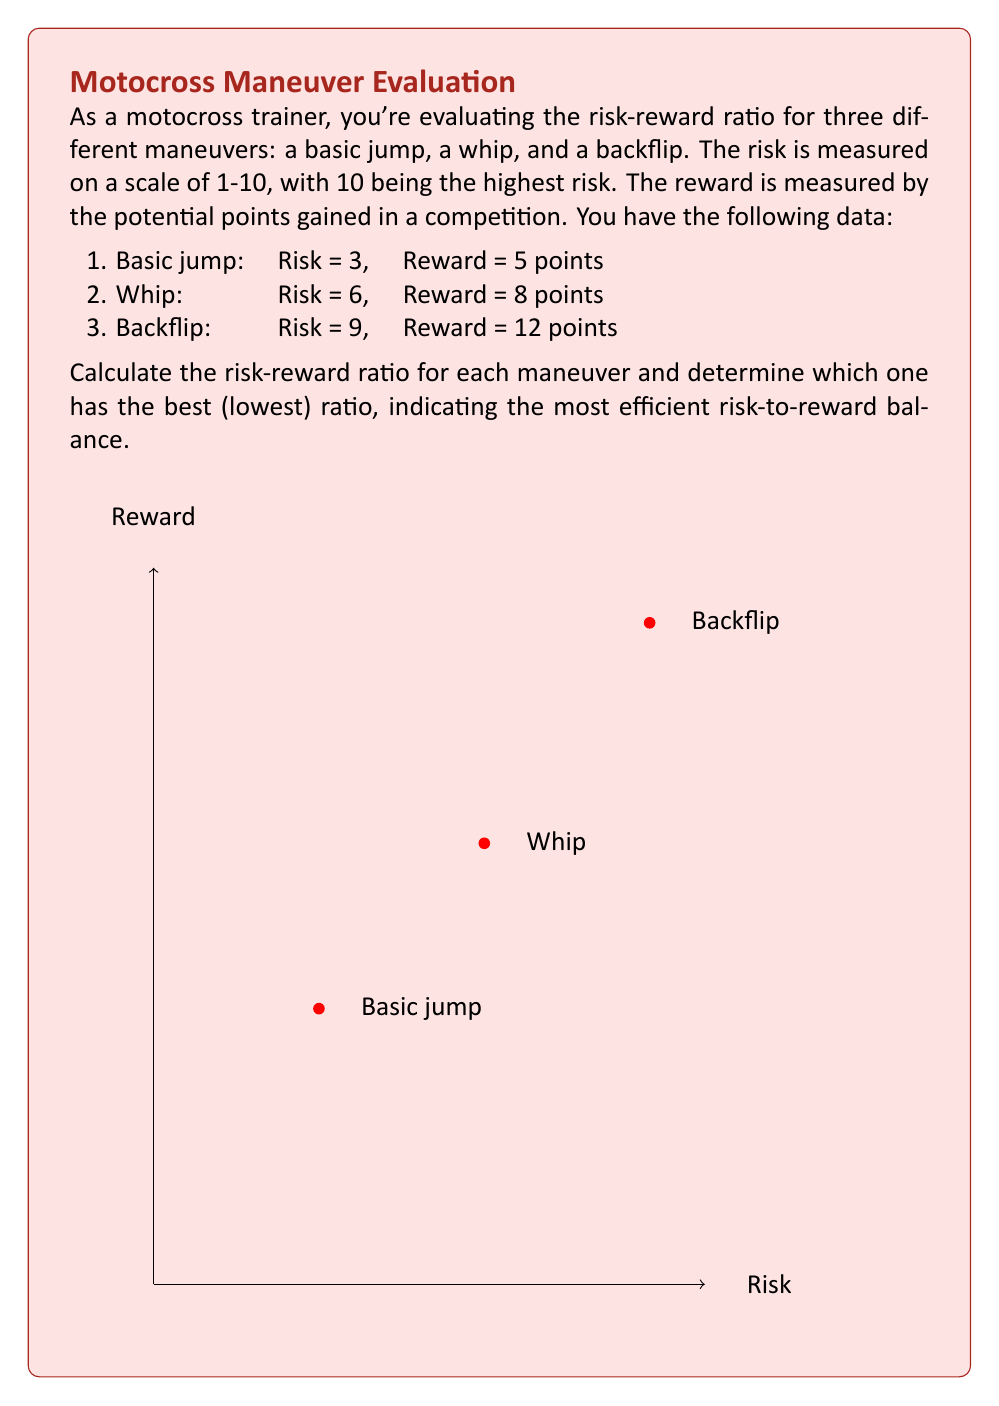Can you answer this question? To solve this problem, we need to calculate the risk-reward ratio for each maneuver and compare them. The risk-reward ratio is calculated by dividing the risk by the reward.

Let's calculate the ratio for each maneuver:

1. Basic jump:
   $$ \text{Ratio} = \frac{\text{Risk}}{\text{Reward}} = \frac{3}{5} = 0.6 $$

2. Whip:
   $$ \text{Ratio} = \frac{\text{Risk}}{\text{Reward}} = \frac{6}{8} = 0.75 $$

3. Backflip:
   $$ \text{Ratio} = \frac{\text{Risk}}{\text{Reward}} = \frac{9}{12} = 0.75 $$

Now, let's compare the ratios:

- Basic jump: 0.6
- Whip: 0.75
- Backflip: 0.75

The lower the ratio, the better the risk-reward balance. Therefore, the basic jump has the best (lowest) risk-reward ratio at 0.6.

This result aligns with a balanced approach between traditional methods and technology. The basic jump, while less spectacular, offers the most efficient risk-to-reward balance, which is crucial for consistent performance and long-term success in motocross.
Answer: Basic jump (ratio: 0.6) 